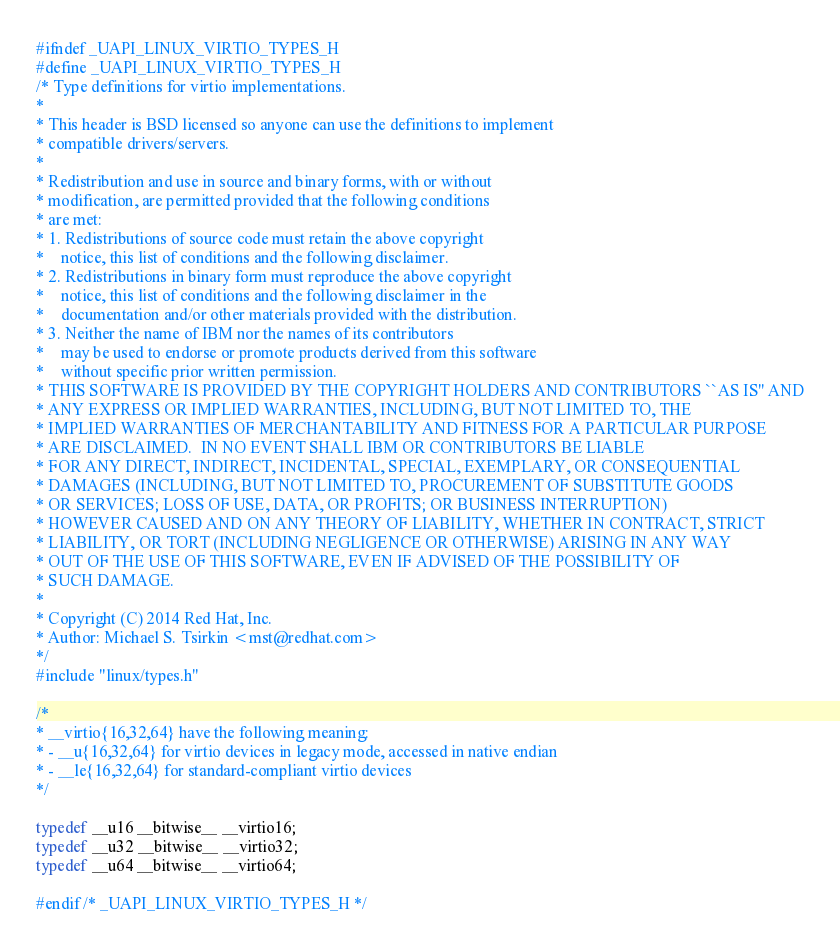<code> <loc_0><loc_0><loc_500><loc_500><_C_>#ifndef _UAPI_LINUX_VIRTIO_TYPES_H
#define _UAPI_LINUX_VIRTIO_TYPES_H
/* Type definitions for virtio implementations.
*
* This header is BSD licensed so anyone can use the definitions to implement
* compatible drivers/servers.
*
* Redistribution and use in source and binary forms, with or without
* modification, are permitted provided that the following conditions
* are met:
* 1. Redistributions of source code must retain the above copyright
*    notice, this list of conditions and the following disclaimer.
* 2. Redistributions in binary form must reproduce the above copyright
*    notice, this list of conditions and the following disclaimer in the
*    documentation and/or other materials provided with the distribution.
* 3. Neither the name of IBM nor the names of its contributors
*    may be used to endorse or promote products derived from this software
*    without specific prior written permission.
* THIS SOFTWARE IS PROVIDED BY THE COPYRIGHT HOLDERS AND CONTRIBUTORS ``AS IS'' AND
* ANY EXPRESS OR IMPLIED WARRANTIES, INCLUDING, BUT NOT LIMITED TO, THE
* IMPLIED WARRANTIES OF MERCHANTABILITY AND FITNESS FOR A PARTICULAR PURPOSE
* ARE DISCLAIMED.  IN NO EVENT SHALL IBM OR CONTRIBUTORS BE LIABLE
* FOR ANY DIRECT, INDIRECT, INCIDENTAL, SPECIAL, EXEMPLARY, OR CONSEQUENTIAL
* DAMAGES (INCLUDING, BUT NOT LIMITED TO, PROCUREMENT OF SUBSTITUTE GOODS
* OR SERVICES; LOSS OF USE, DATA, OR PROFITS; OR BUSINESS INTERRUPTION)
* HOWEVER CAUSED AND ON ANY THEORY OF LIABILITY, WHETHER IN CONTRACT, STRICT
* LIABILITY, OR TORT (INCLUDING NEGLIGENCE OR OTHERWISE) ARISING IN ANY WAY
* OUT OF THE USE OF THIS SOFTWARE, EVEN IF ADVISED OF THE POSSIBILITY OF
* SUCH DAMAGE.
*
* Copyright (C) 2014 Red Hat, Inc.
* Author: Michael S. Tsirkin <mst@redhat.com>
*/
#include "linux/types.h"

/*
* __virtio{16,32,64} have the following meaning:
* - __u{16,32,64} for virtio devices in legacy mode, accessed in native endian
* - __le{16,32,64} for standard-compliant virtio devices
*/

typedef __u16 __bitwise__ __virtio16;
typedef __u32 __bitwise__ __virtio32;
typedef __u64 __bitwise__ __virtio64;

#endif /* _UAPI_LINUX_VIRTIO_TYPES_H */
</code> 